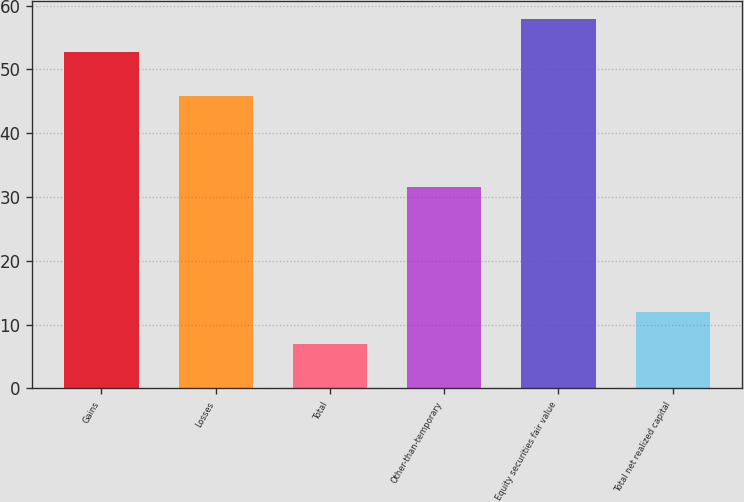Convert chart. <chart><loc_0><loc_0><loc_500><loc_500><bar_chart><fcel>Gains<fcel>Losses<fcel>Total<fcel>Other-than-temporary<fcel>Equity securities fair value<fcel>Total net realized capital<nl><fcel>52.8<fcel>45.9<fcel>6.9<fcel>31.6<fcel>57.88<fcel>11.98<nl></chart> 